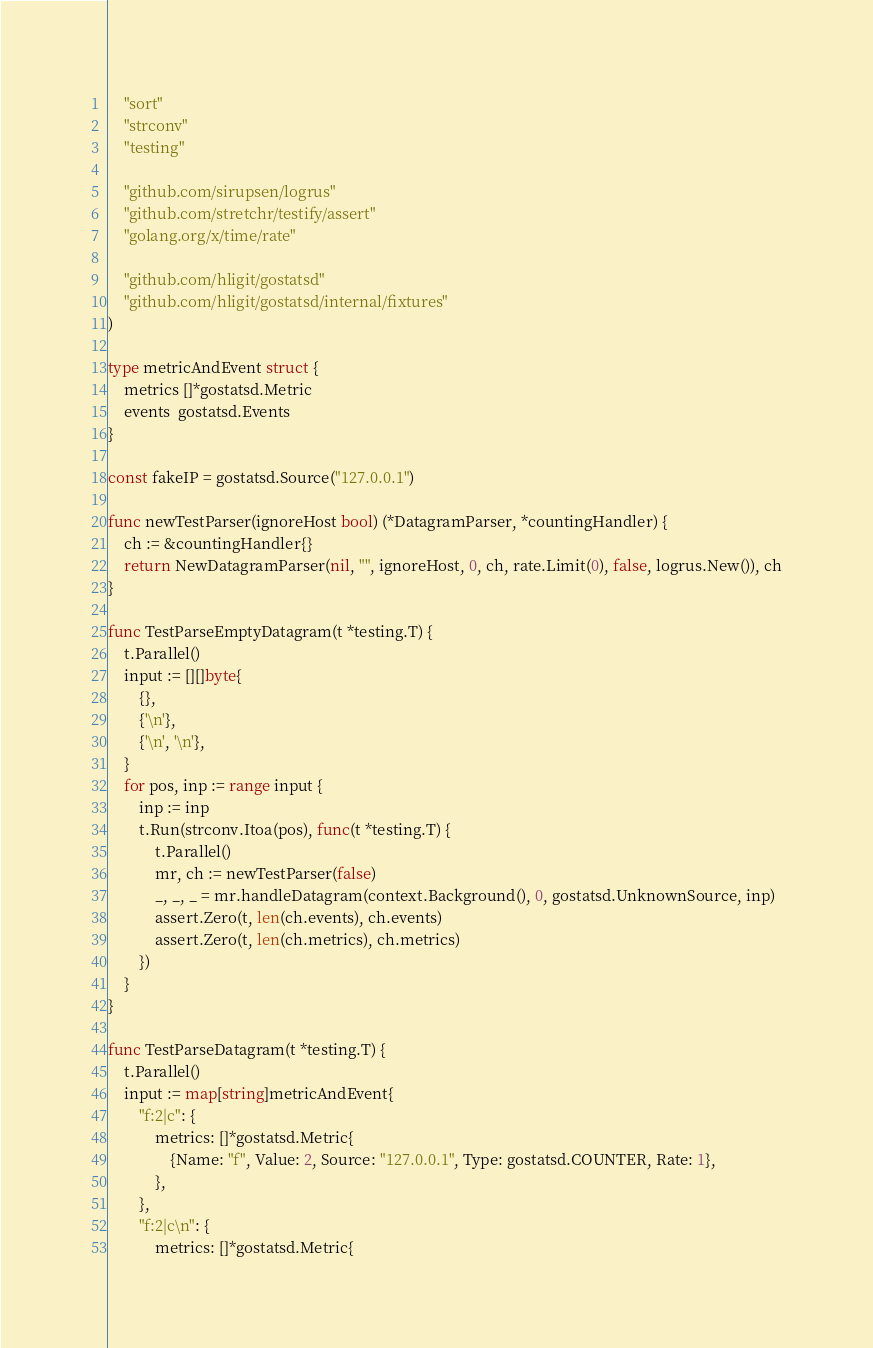Convert code to text. <code><loc_0><loc_0><loc_500><loc_500><_Go_>	"sort"
	"strconv"
	"testing"

	"github.com/sirupsen/logrus"
	"github.com/stretchr/testify/assert"
	"golang.org/x/time/rate"

	"github.com/hligit/gostatsd"
	"github.com/hligit/gostatsd/internal/fixtures"
)

type metricAndEvent struct {
	metrics []*gostatsd.Metric
	events  gostatsd.Events
}

const fakeIP = gostatsd.Source("127.0.0.1")

func newTestParser(ignoreHost bool) (*DatagramParser, *countingHandler) {
	ch := &countingHandler{}
	return NewDatagramParser(nil, "", ignoreHost, 0, ch, rate.Limit(0), false, logrus.New()), ch
}

func TestParseEmptyDatagram(t *testing.T) {
	t.Parallel()
	input := [][]byte{
		{},
		{'\n'},
		{'\n', '\n'},
	}
	for pos, inp := range input {
		inp := inp
		t.Run(strconv.Itoa(pos), func(t *testing.T) {
			t.Parallel()
			mr, ch := newTestParser(false)
			_, _, _ = mr.handleDatagram(context.Background(), 0, gostatsd.UnknownSource, inp)
			assert.Zero(t, len(ch.events), ch.events)
			assert.Zero(t, len(ch.metrics), ch.metrics)
		})
	}
}

func TestParseDatagram(t *testing.T) {
	t.Parallel()
	input := map[string]metricAndEvent{
		"f:2|c": {
			metrics: []*gostatsd.Metric{
				{Name: "f", Value: 2, Source: "127.0.0.1", Type: gostatsd.COUNTER, Rate: 1},
			},
		},
		"f:2|c\n": {
			metrics: []*gostatsd.Metric{</code> 